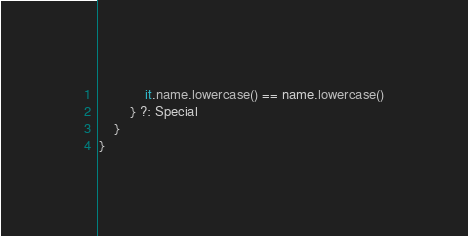Convert code to text. <code><loc_0><loc_0><loc_500><loc_500><_Kotlin_>            it.name.lowercase() == name.lowercase()
        } ?: Special
    }
}</code> 